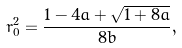<formula> <loc_0><loc_0><loc_500><loc_500>r _ { 0 } ^ { 2 } = \frac { 1 - 4 a + \sqrt { 1 + 8 a } } { 8 b } ,</formula> 